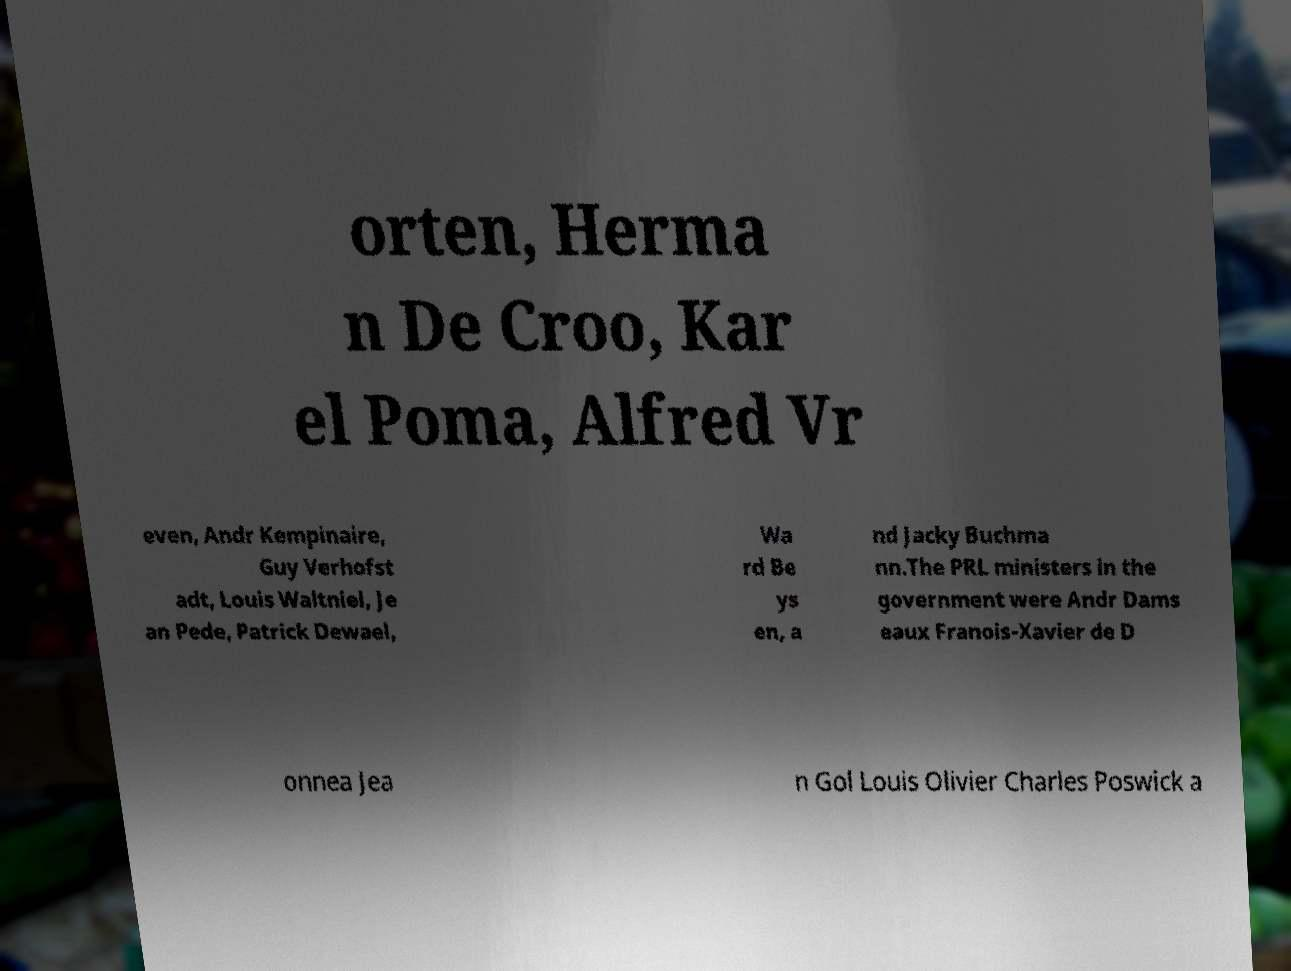Please identify and transcribe the text found in this image. orten, Herma n De Croo, Kar el Poma, Alfred Vr even, Andr Kempinaire, Guy Verhofst adt, Louis Waltniel, Je an Pede, Patrick Dewael, Wa rd Be ys en, a nd Jacky Buchma nn.The PRL ministers in the government were Andr Dams eaux Franois-Xavier de D onnea Jea n Gol Louis Olivier Charles Poswick a 